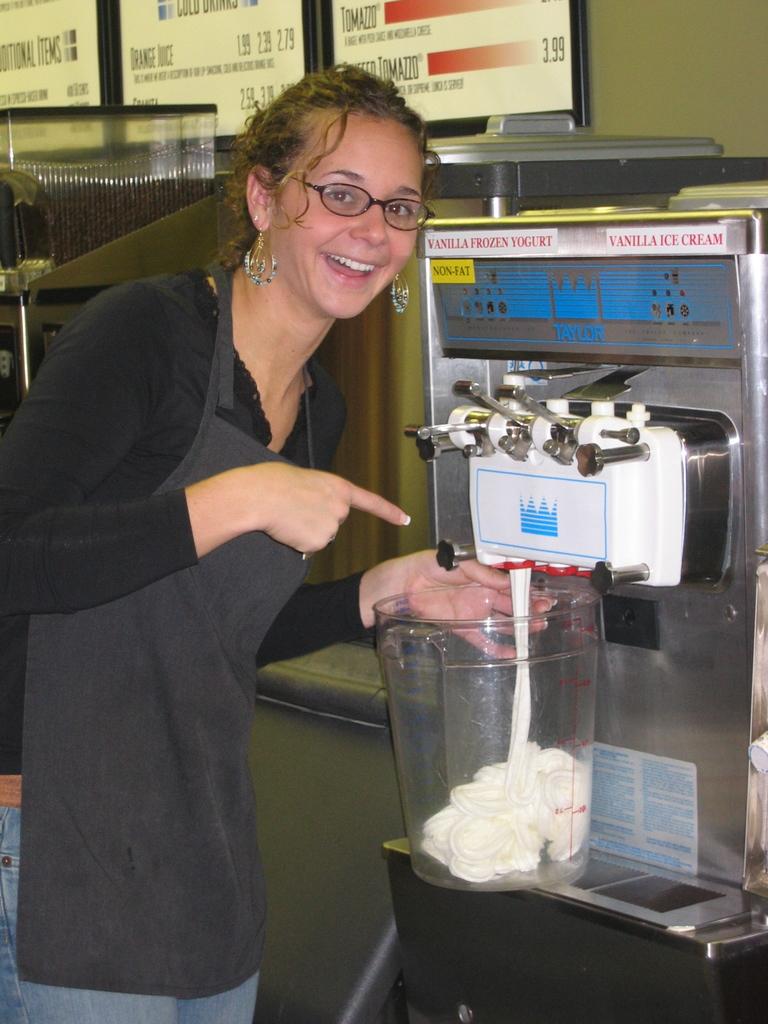What is one of the costs for an item on the menu?
Offer a terse response. 3.99. What is this machine used for?
Keep it short and to the point. Answering does not require reading text in the image. 